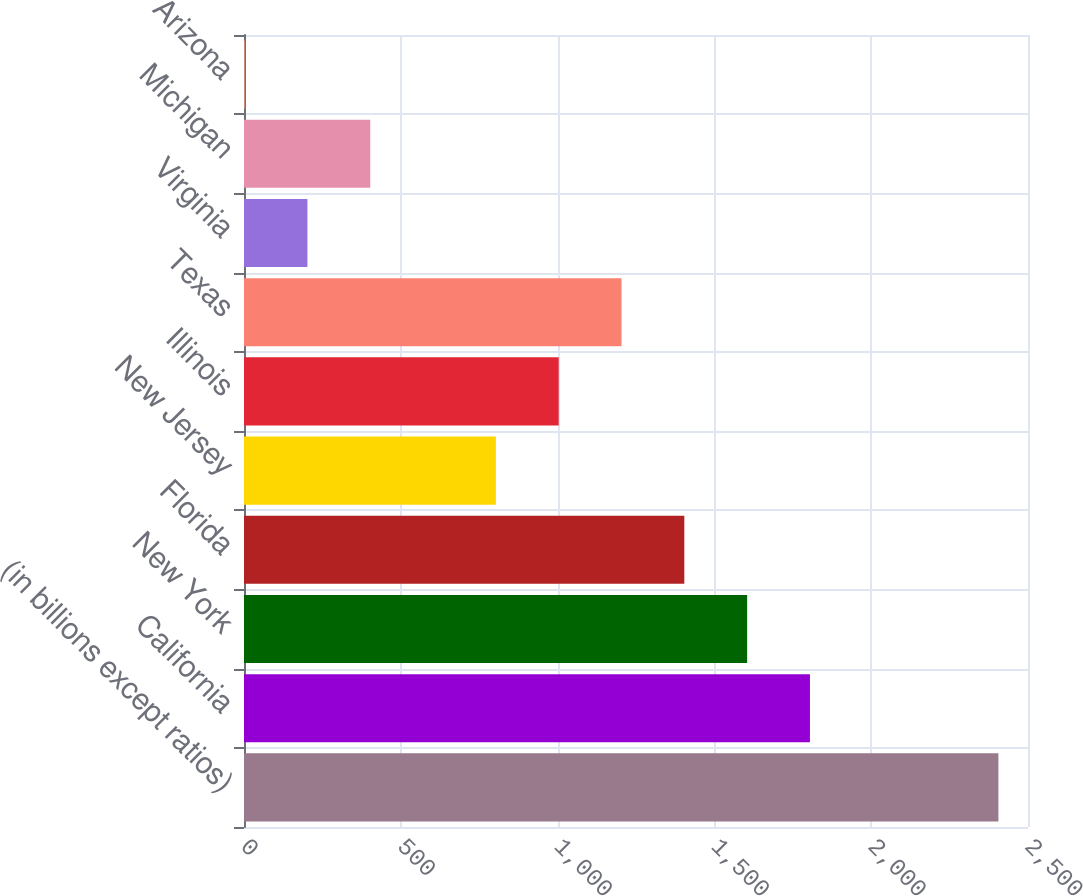Convert chart to OTSL. <chart><loc_0><loc_0><loc_500><loc_500><bar_chart><fcel>(in billions except ratios)<fcel>California<fcel>New York<fcel>Florida<fcel>New Jersey<fcel>Illinois<fcel>Texas<fcel>Virginia<fcel>Michigan<fcel>Arizona<nl><fcel>2405.6<fcel>1804.7<fcel>1604.4<fcel>1404.1<fcel>803.2<fcel>1003.5<fcel>1203.8<fcel>202.3<fcel>402.6<fcel>2<nl></chart> 